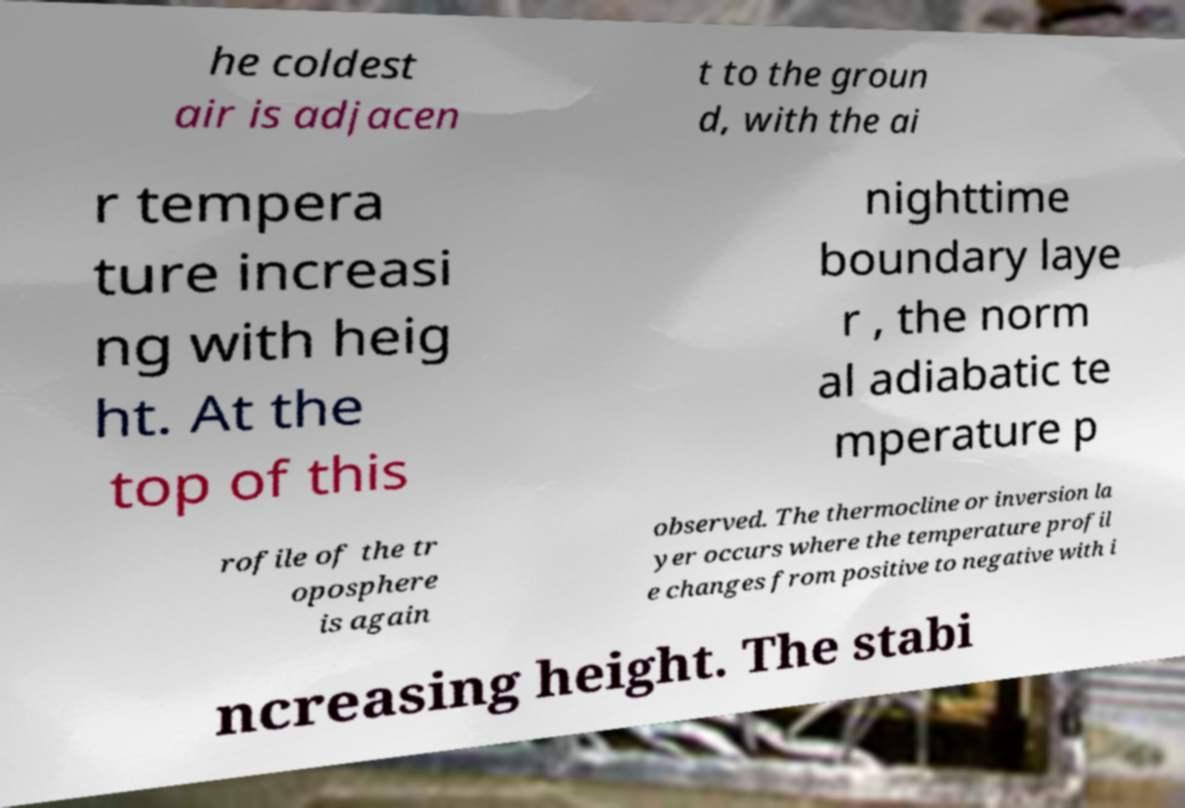For documentation purposes, I need the text within this image transcribed. Could you provide that? he coldest air is adjacen t to the groun d, with the ai r tempera ture increasi ng with heig ht. At the top of this nighttime boundary laye r , the norm al adiabatic te mperature p rofile of the tr oposphere is again observed. The thermocline or inversion la yer occurs where the temperature profil e changes from positive to negative with i ncreasing height. The stabi 